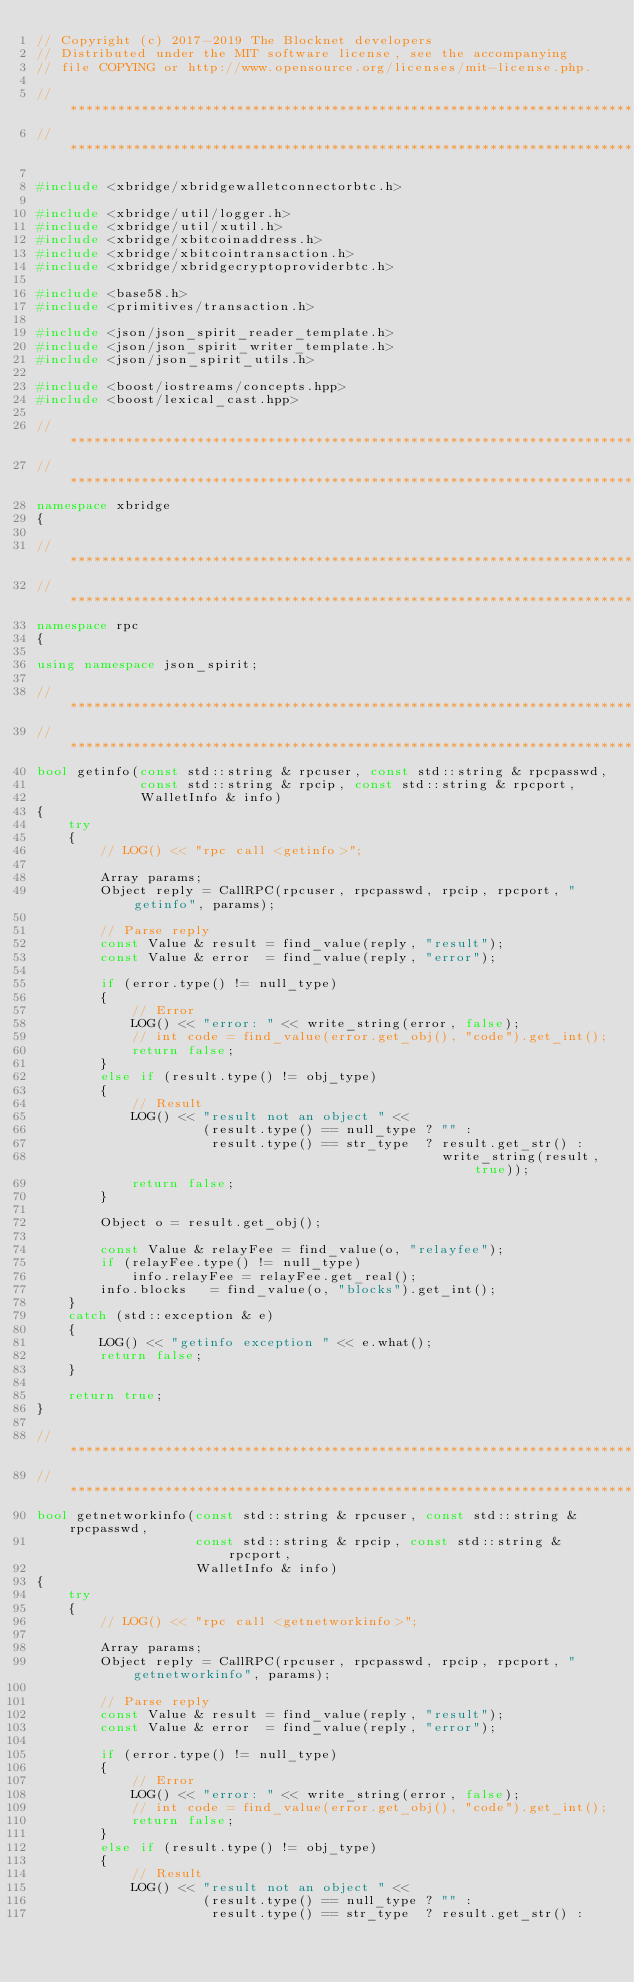Convert code to text. <code><loc_0><loc_0><loc_500><loc_500><_C++_>// Copyright (c) 2017-2019 The Blocknet developers
// Distributed under the MIT software license, see the accompanying
// file COPYING or http://www.opensource.org/licenses/mit-license.php.

//*****************************************************************************
//*****************************************************************************

#include <xbridge/xbridgewalletconnectorbtc.h>

#include <xbridge/util/logger.h>
#include <xbridge/util/xutil.h>
#include <xbridge/xbitcoinaddress.h>
#include <xbridge/xbitcointransaction.h>
#include <xbridge/xbridgecryptoproviderbtc.h>

#include <base58.h>
#include <primitives/transaction.h>

#include <json/json_spirit_reader_template.h>
#include <json/json_spirit_writer_template.h>
#include <json/json_spirit_utils.h>

#include <boost/iostreams/concepts.hpp>
#include <boost/lexical_cast.hpp>

//*****************************************************************************
//*****************************************************************************
namespace xbridge
{

//*****************************************************************************
//*****************************************************************************
namespace rpc
{

using namespace json_spirit;

//*****************************************************************************
//*****************************************************************************
bool getinfo(const std::string & rpcuser, const std::string & rpcpasswd,
             const std::string & rpcip, const std::string & rpcport,
             WalletInfo & info)
{
    try
    {
        // LOG() << "rpc call <getinfo>";

        Array params;
        Object reply = CallRPC(rpcuser, rpcpasswd, rpcip, rpcport, "getinfo", params);

        // Parse reply
        const Value & result = find_value(reply, "result");
        const Value & error  = find_value(reply, "error");

        if (error.type() != null_type)
        {
            // Error
            LOG() << "error: " << write_string(error, false);
            // int code = find_value(error.get_obj(), "code").get_int();
            return false;
        }
        else if (result.type() != obj_type)
        {
            // Result
            LOG() << "result not an object " <<
                     (result.type() == null_type ? "" :
                      result.type() == str_type  ? result.get_str() :
                                                   write_string(result, true));
            return false;
        }

        Object o = result.get_obj();

        const Value & relayFee = find_value(o, "relayfee");
        if (relayFee.type() != null_type)
            info.relayFee = relayFee.get_real();
        info.blocks   = find_value(o, "blocks").get_int();
    }
    catch (std::exception & e)
    {
        LOG() << "getinfo exception " << e.what();
        return false;
    }

    return true;
}

//*****************************************************************************
//*****************************************************************************
bool getnetworkinfo(const std::string & rpcuser, const std::string & rpcpasswd,
                    const std::string & rpcip, const std::string & rpcport,
                    WalletInfo & info)
{
    try
    {
        // LOG() << "rpc call <getnetworkinfo>";

        Array params;
        Object reply = CallRPC(rpcuser, rpcpasswd, rpcip, rpcport, "getnetworkinfo", params);

        // Parse reply
        const Value & result = find_value(reply, "result");
        const Value & error  = find_value(reply, "error");

        if (error.type() != null_type)
        {
            // Error
            LOG() << "error: " << write_string(error, false);
            // int code = find_value(error.get_obj(), "code").get_int();
            return false;
        }
        else if (result.type() != obj_type)
        {
            // Result
            LOG() << "result not an object " <<
                     (result.type() == null_type ? "" :
                      result.type() == str_type  ? result.get_str() :</code> 